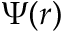<formula> <loc_0><loc_0><loc_500><loc_500>\Psi ( r )</formula> 